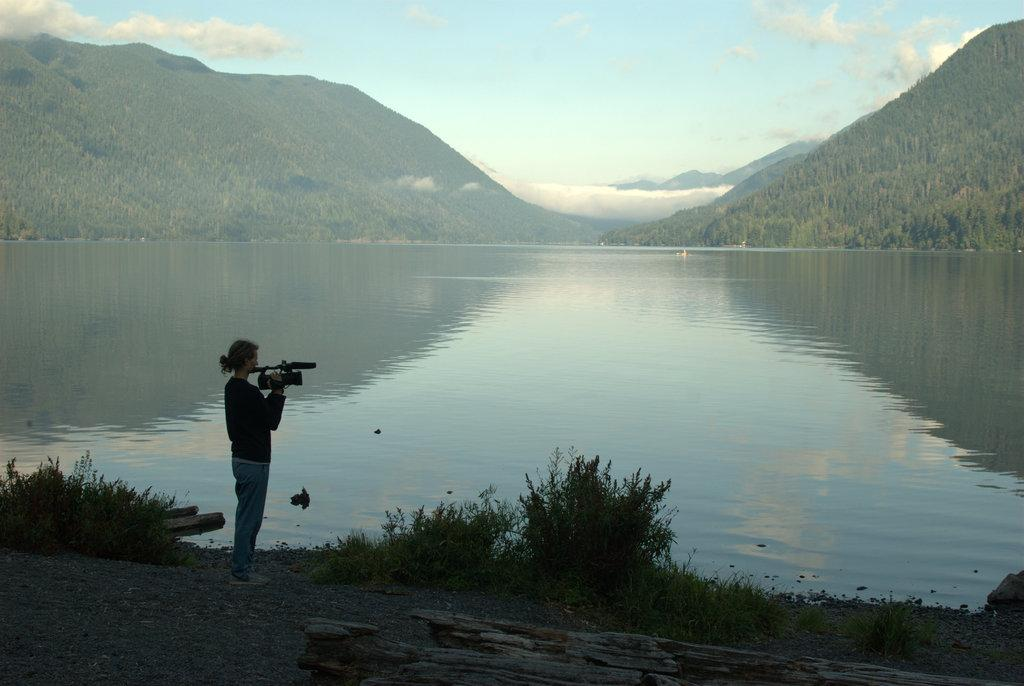What is the person in the image doing? The person is standing on the ground and holding a camera. What can be seen in the background of the image? There are trees, water, mountains, and the sky visible in the background of the image. What is the condition of the sky in the image? Clouds are present in the sky. What type of string is being used to tie the cup to the person's grade in the image? There is no string, cup, or mention of a grade present in the image. 